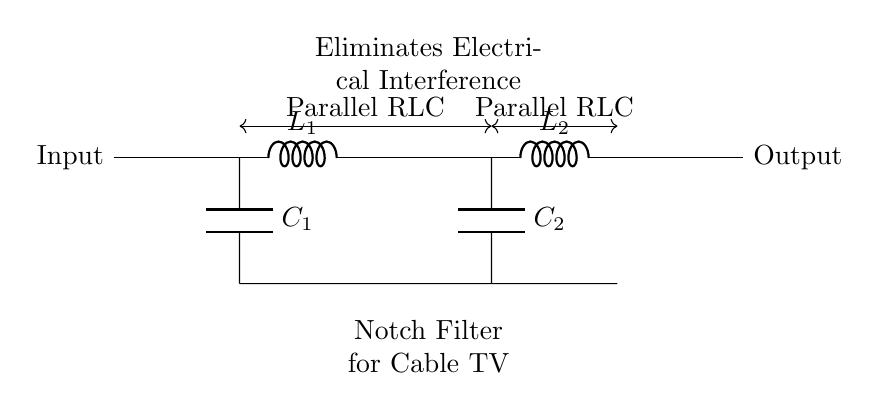What is the total number of inductors in this circuit? The circuit diagram shows two inductors labeled L1 and L2. By counting them, the total number is two.
Answer: 2 What is the role of a notch filter? A notch filter is designed to eliminate specific frequency components from a signal. This is shown by the label indicating that it removes electrical interference in cable TV signals.
Answer: Eliminate interference How many capacitors are present in the circuit? There are two capacitors labeled C1 and C2 visible in the circuit diagram. Therefore, the total count is two.
Answer: 2 What is the function of C1 in this circuit? Capacitor C1 is part of a parallel RLC circuit and contributes to the filtering effect of the notch filter. This indicates that it plays a role in allowing certain frequencies to pass while blocking others.
Answer: Filtering What is connected to the input of this filter? The input of the filter is connected to an unspecified signal source that feeds the RLC components. It is labeled simply as "Input" in the diagram, indicating where the signal enters.
Answer: Input signal Which components are part of the parallel configuration in this circuit? The components in the parallel configuration include both C1 and C2 as well as L1 and L2. This is demonstrated by the connections shown in the diagram which indicate that these elements are arranged in parallel form.
Answer: C1, C2, L1, L2 